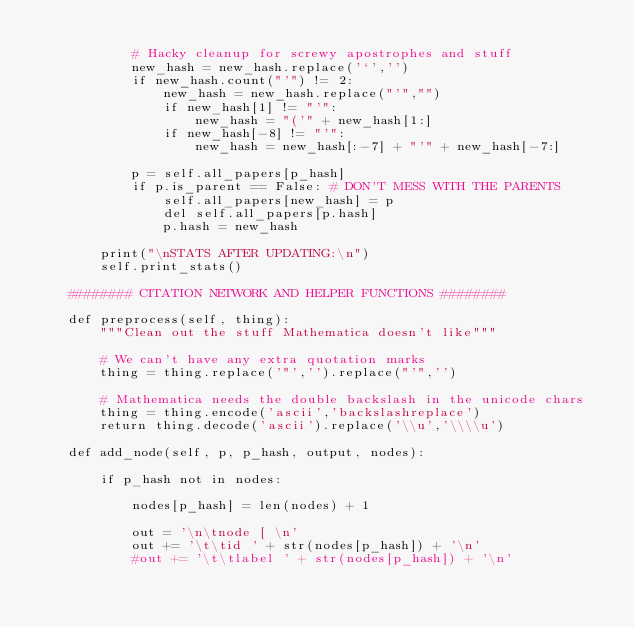Convert code to text. <code><loc_0><loc_0><loc_500><loc_500><_Python_>
			# Hacky cleanup for screwy apostrophes and stuff
			new_hash = new_hash.replace('`','')
			if new_hash.count("'") != 2:
				new_hash = new_hash.replace("'","")
				if new_hash[1] != "'":
					new_hash = "('" + new_hash[1:]
				if new_hash[-8] != "'":
					new_hash = new_hash[:-7] + "'" + new_hash[-7:]

			p = self.all_papers[p_hash]
			if p.is_parent == False: # DON'T MESS WITH THE PARENTS
				self.all_papers[new_hash] = p
				del self.all_papers[p.hash]
				p.hash = new_hash

		print("\nSTATS AFTER UPDATING:\n")
		self.print_stats()

	######## CITATION NETWORK AND HELPER FUNCTIONS ######## 
	
	def preprocess(self, thing):
		"""Clean out the stuff Mathematica doesn't like"""
		
		# We can't have any extra quotation marks
		thing = thing.replace('"','').replace("'",'')

		# Mathematica needs the double backslash in the unicode chars
		thing = thing.encode('ascii','backslashreplace')
		return thing.decode('ascii').replace('\\u','\\\\u')

	def add_node(self, p, p_hash, output, nodes):
		
		if p_hash not in nodes:
			
			nodes[p_hash] = len(nodes) + 1

			out = '\n\tnode [ \n'
			out += '\t\tid ' + str(nodes[p_hash]) + '\n'
			#out += '\t\tlabel ' + str(nodes[p_hash]) + '\n'</code> 